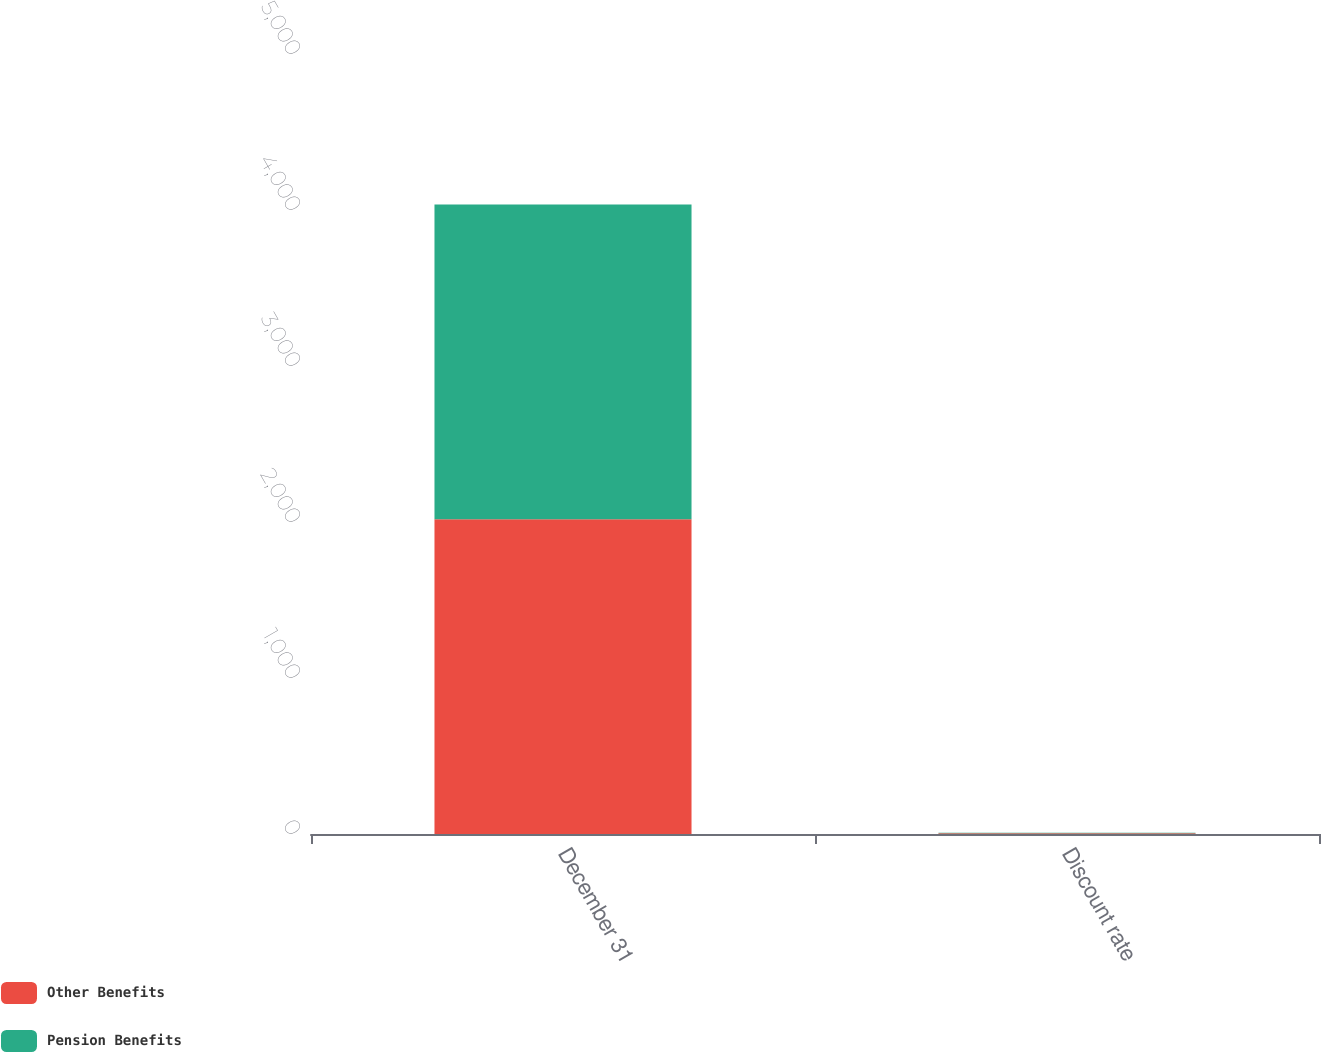Convert chart. <chart><loc_0><loc_0><loc_500><loc_500><stacked_bar_chart><ecel><fcel>December 31<fcel>Discount rate<nl><fcel>Other Benefits<fcel>2018<fcel>4.1<nl><fcel>Pension Benefits<fcel>2018<fcel>4.2<nl></chart> 